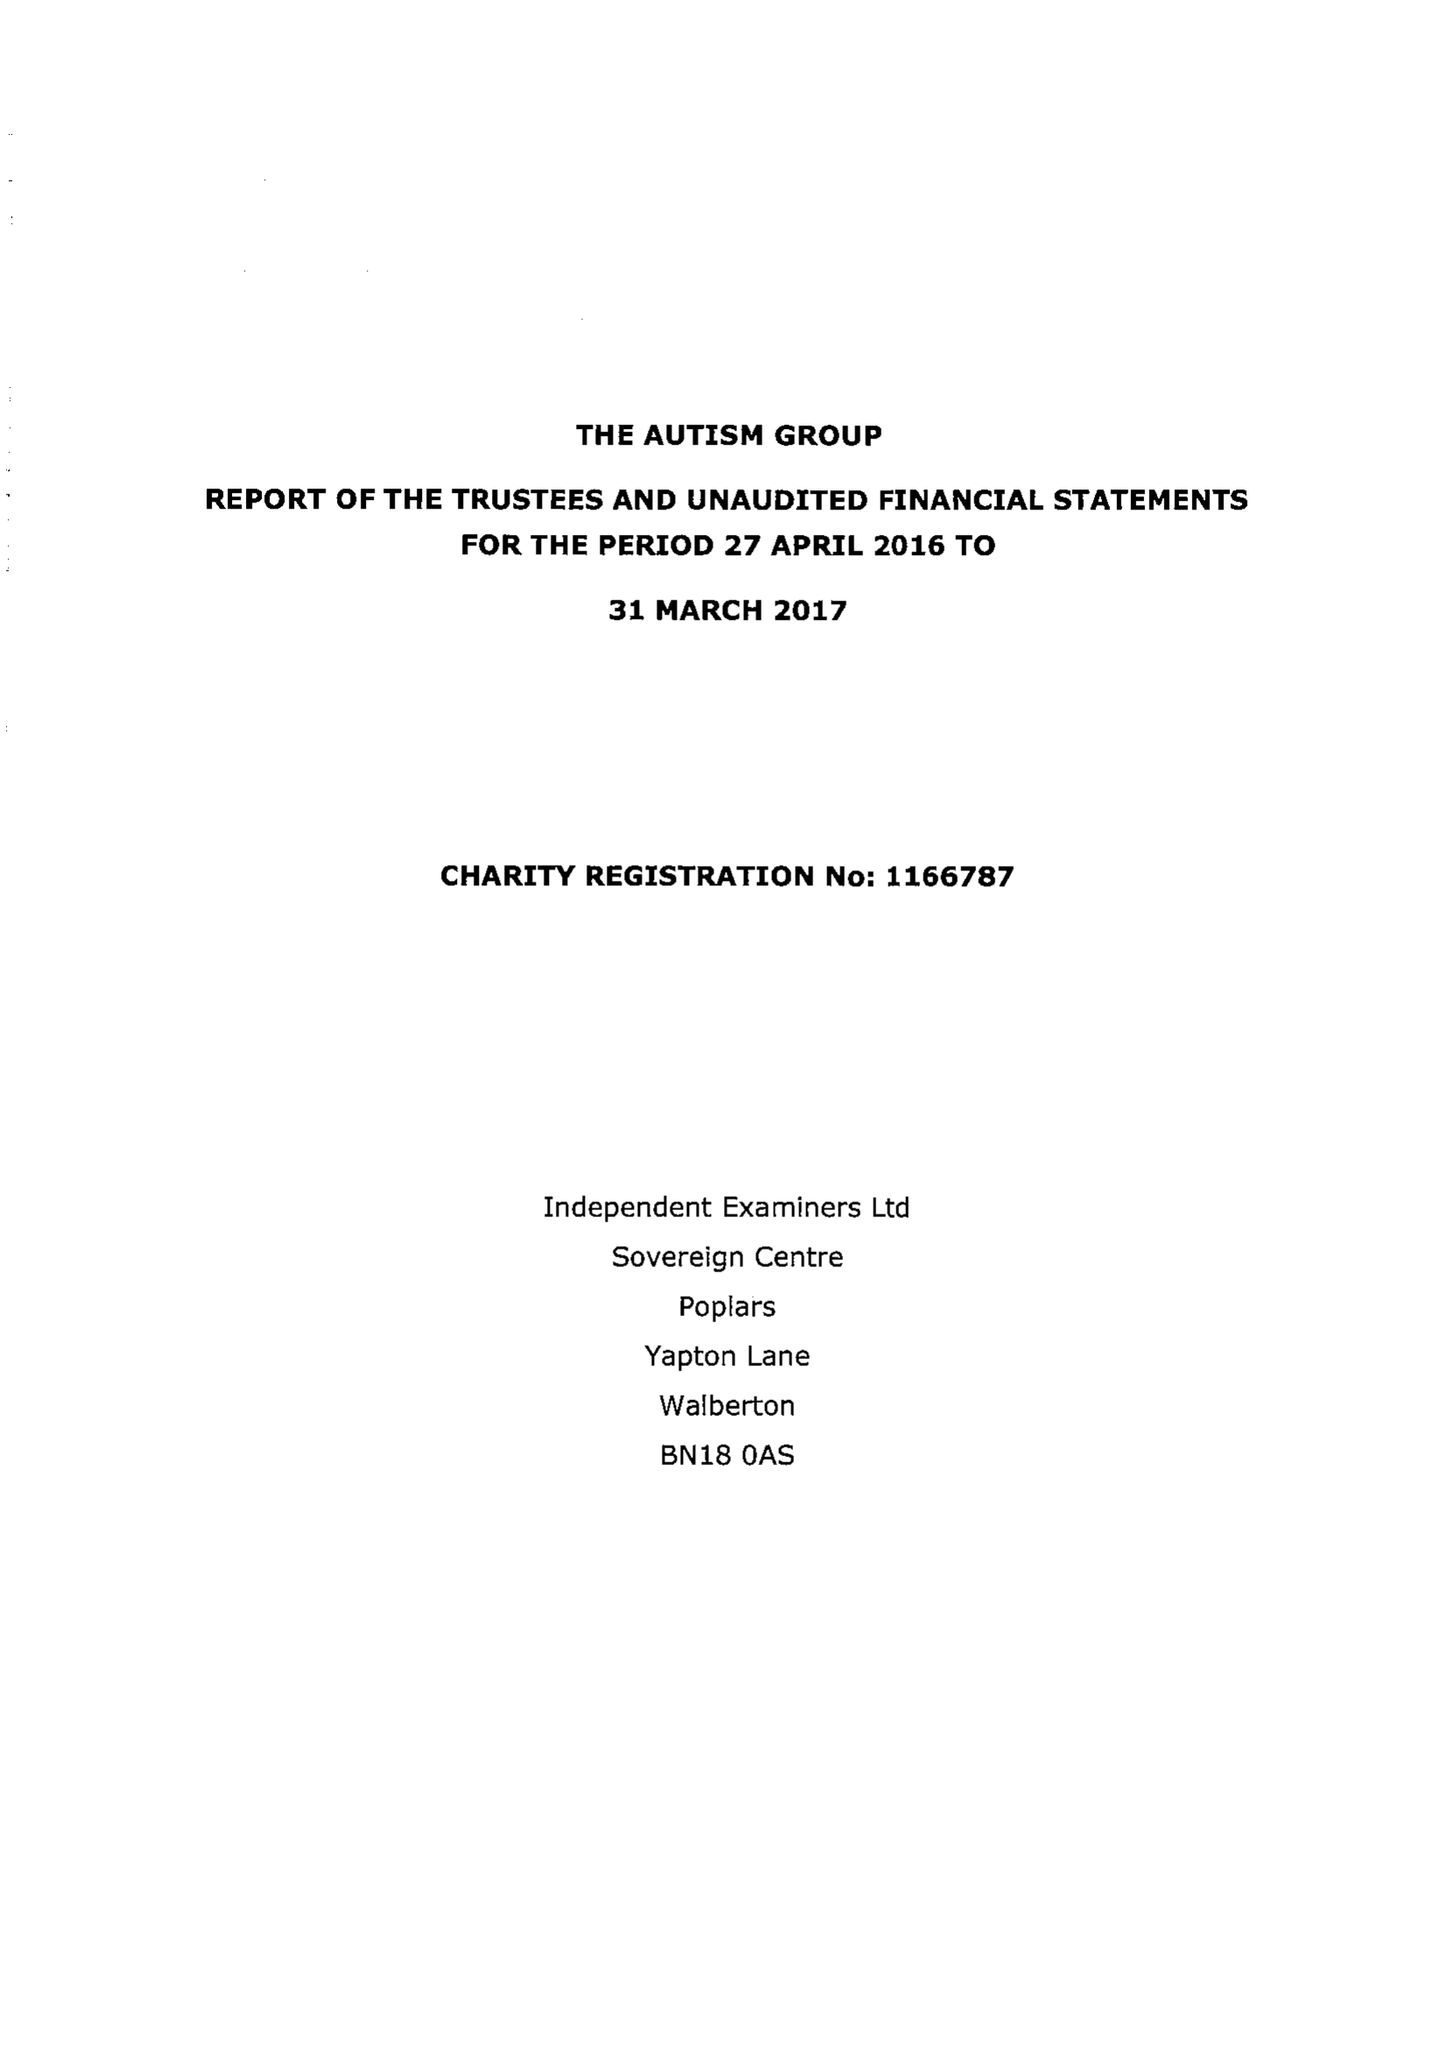What is the value for the charity_number?
Answer the question using a single word or phrase. 1166787 